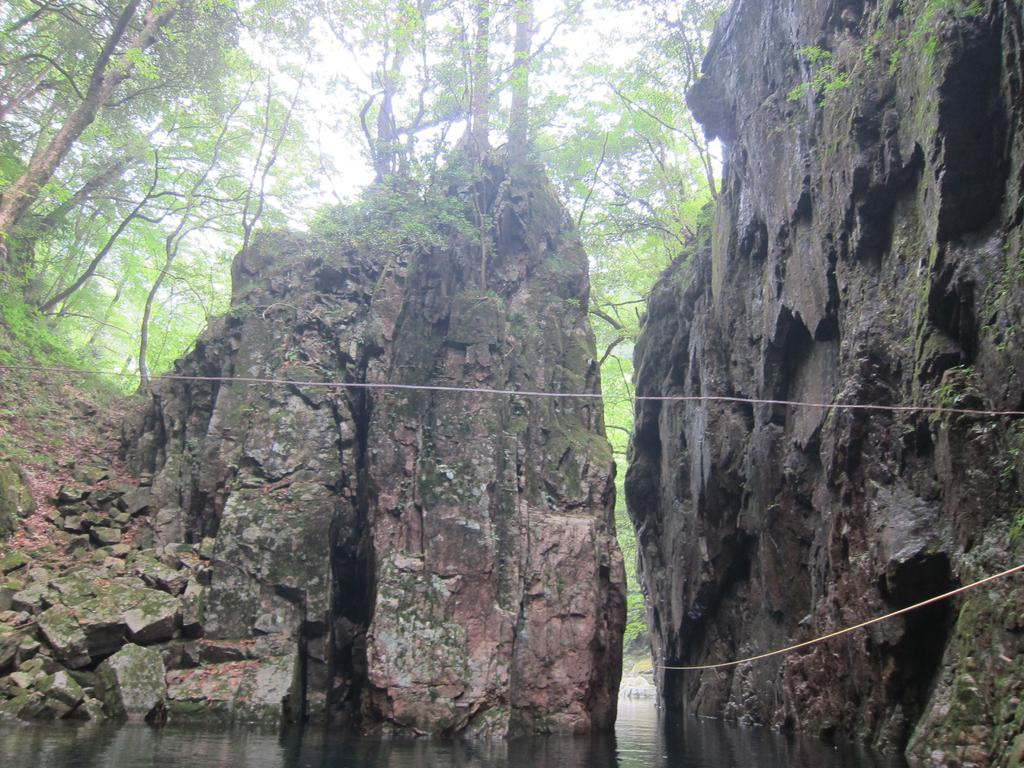What type of natural elements can be seen in the image? There are stones, a big rock, water, grass, and the sky visible in the image. Can you describe the landscape in the image? The image features a landscape with stones, a big rock, water, and grass. What is the color of the sky in the image? The sky is visible in the image, but the color is not mentioned in the facts. What type of vegetation is present in the image? Grass is present in the image. Can you tell me how many bees are buzzing around the baby in the image? There is no baby or bees present in the image; it features stones, a big rock, water, and grass. 